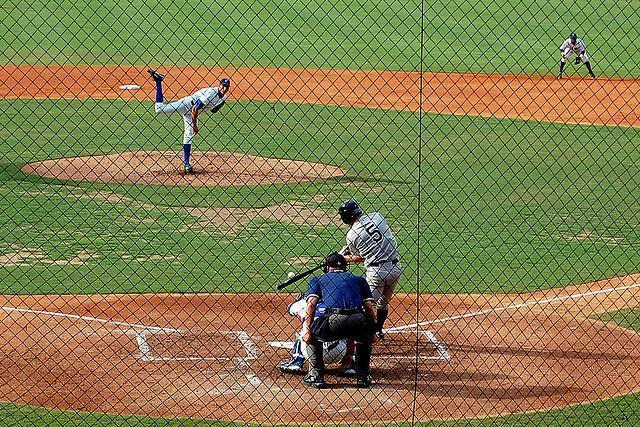How many people are in this photo?
Give a very brief answer. 5. How many people are there?
Give a very brief answer. 3. 